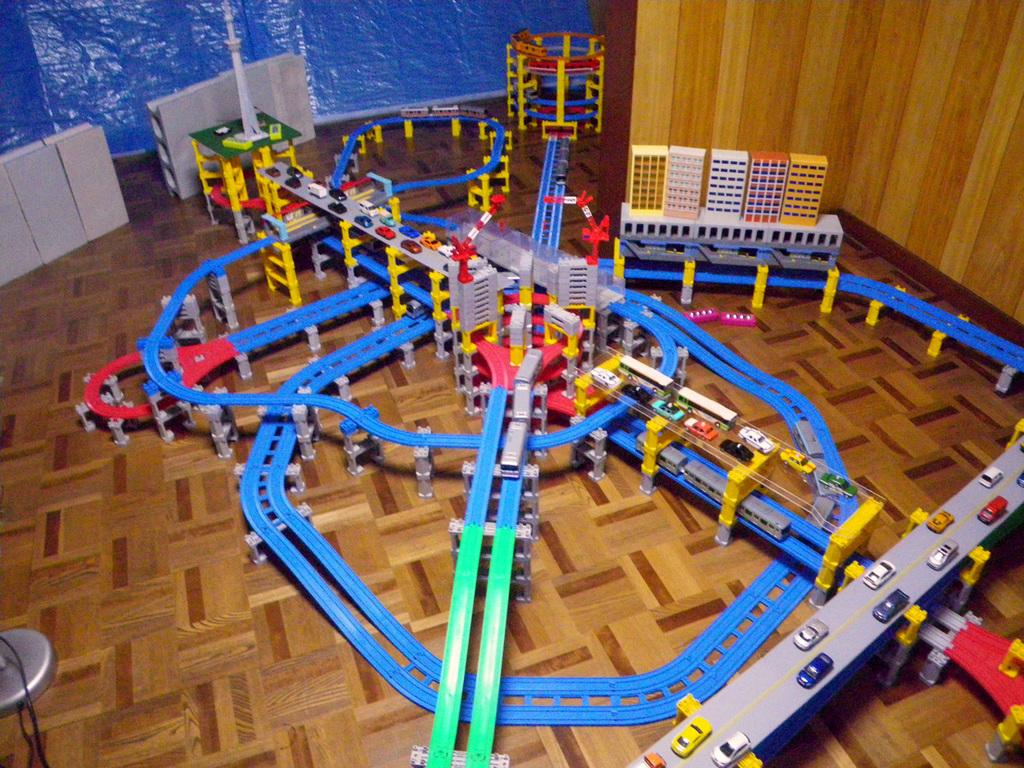What type of object is on the floor in the image? There is a miniature toy set on the floor in the image. Can you describe the location of the toy set in the image? The toy set is on the floor in the image. What else can be seen in the image besides the toy set? There is a wall visible in the image. What type of fuel is required to power the miniature toy set in the image? There is no indication in the image that the miniature toy set requires fuel to operate, as it is likely a static display. 